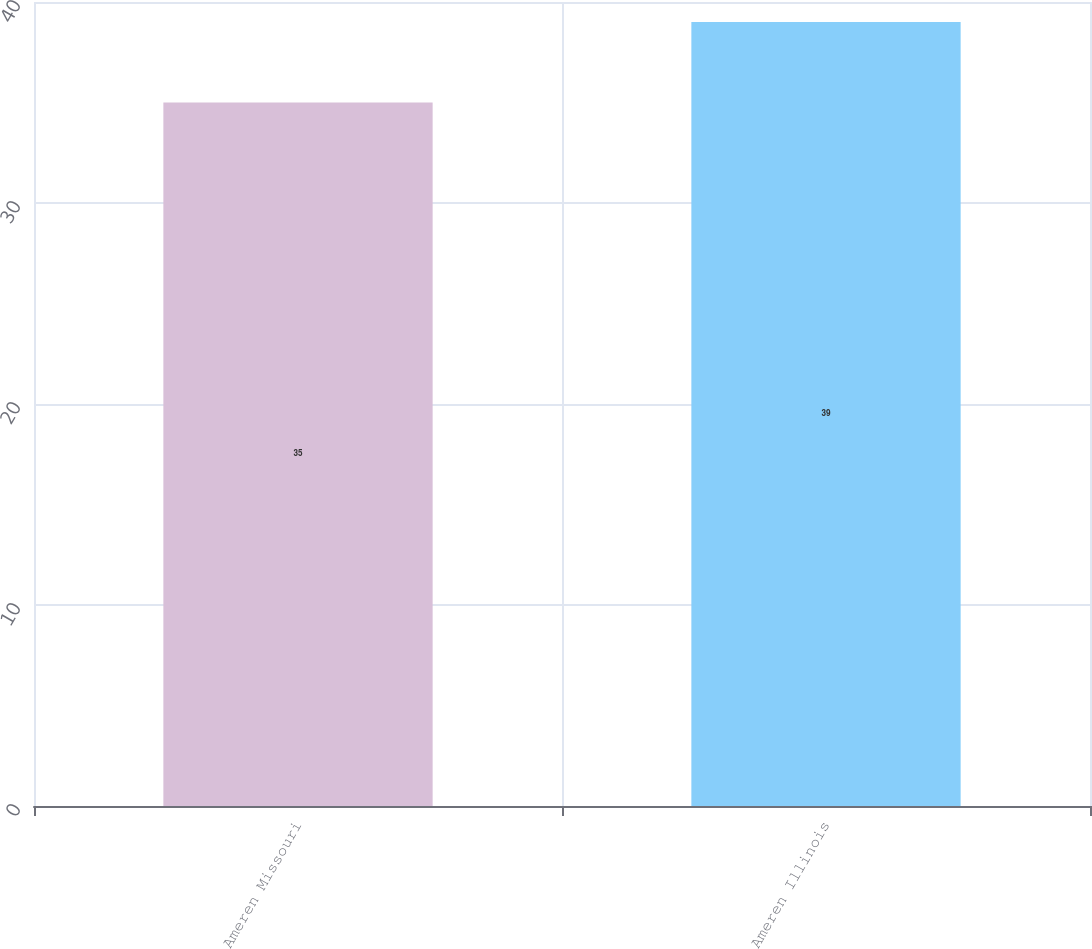Convert chart to OTSL. <chart><loc_0><loc_0><loc_500><loc_500><bar_chart><fcel>Ameren Missouri<fcel>Ameren Illinois<nl><fcel>35<fcel>39<nl></chart> 